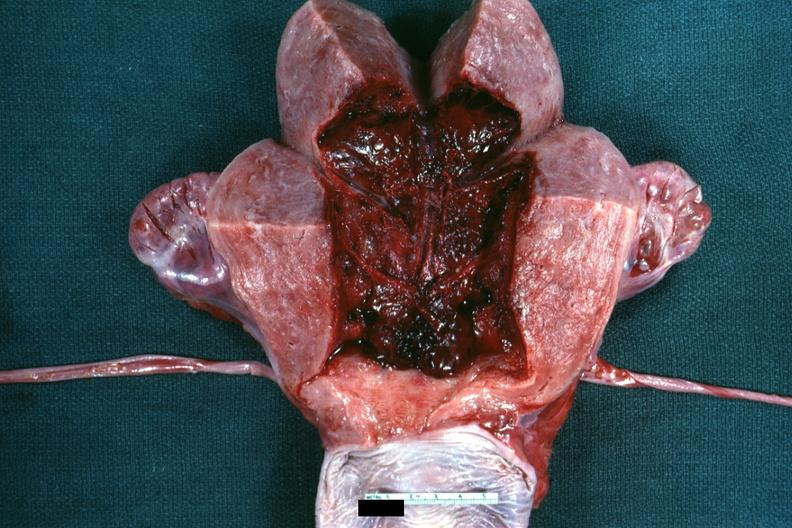what is present?
Answer the question using a single word or phrase. Postpartum 